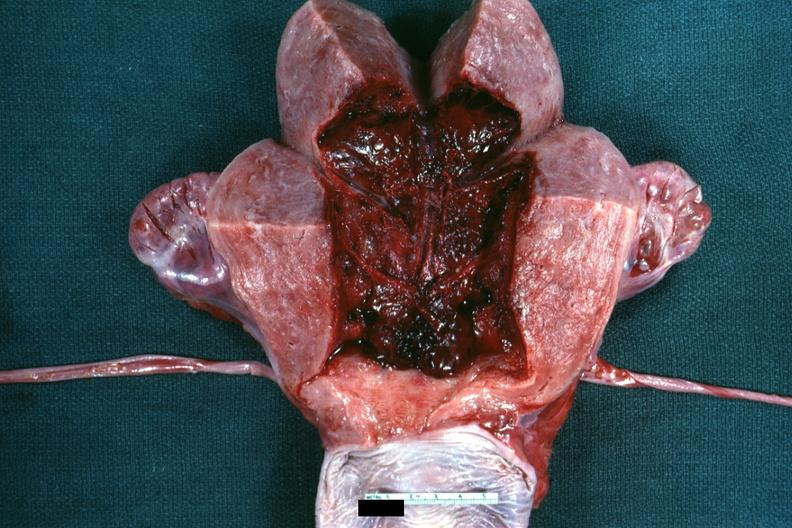what is present?
Answer the question using a single word or phrase. Postpartum 